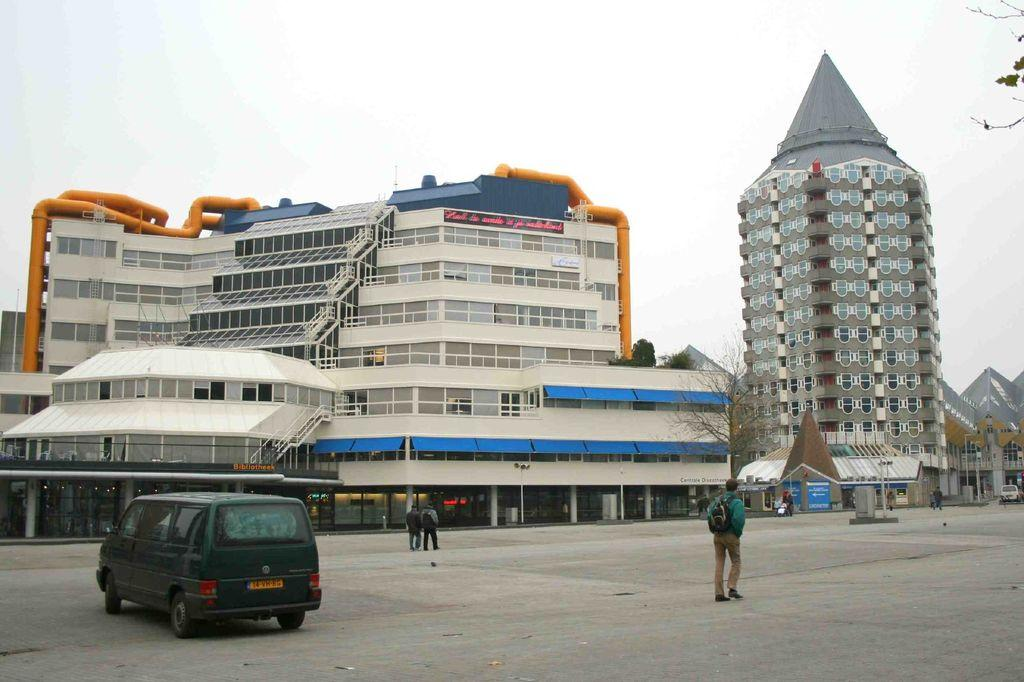What types of vehicles can be seen in the image? There are vehicles in the image, but the specific types are not mentioned. What is happening on the road in the image? There is a group of people on the road in the image. What can be seen in the background of the image? There are buildings, windows, trees, and the sky visible in the background of the image. Where was the image taken? The image appears to be taken on a road. Can you tell me how many ears are visible in the image? There is no mention of ears in the image; it features vehicles, a group of people, buildings, windows, trees, and the sky. What type of market is shown in the image? There is no market present in the image. 